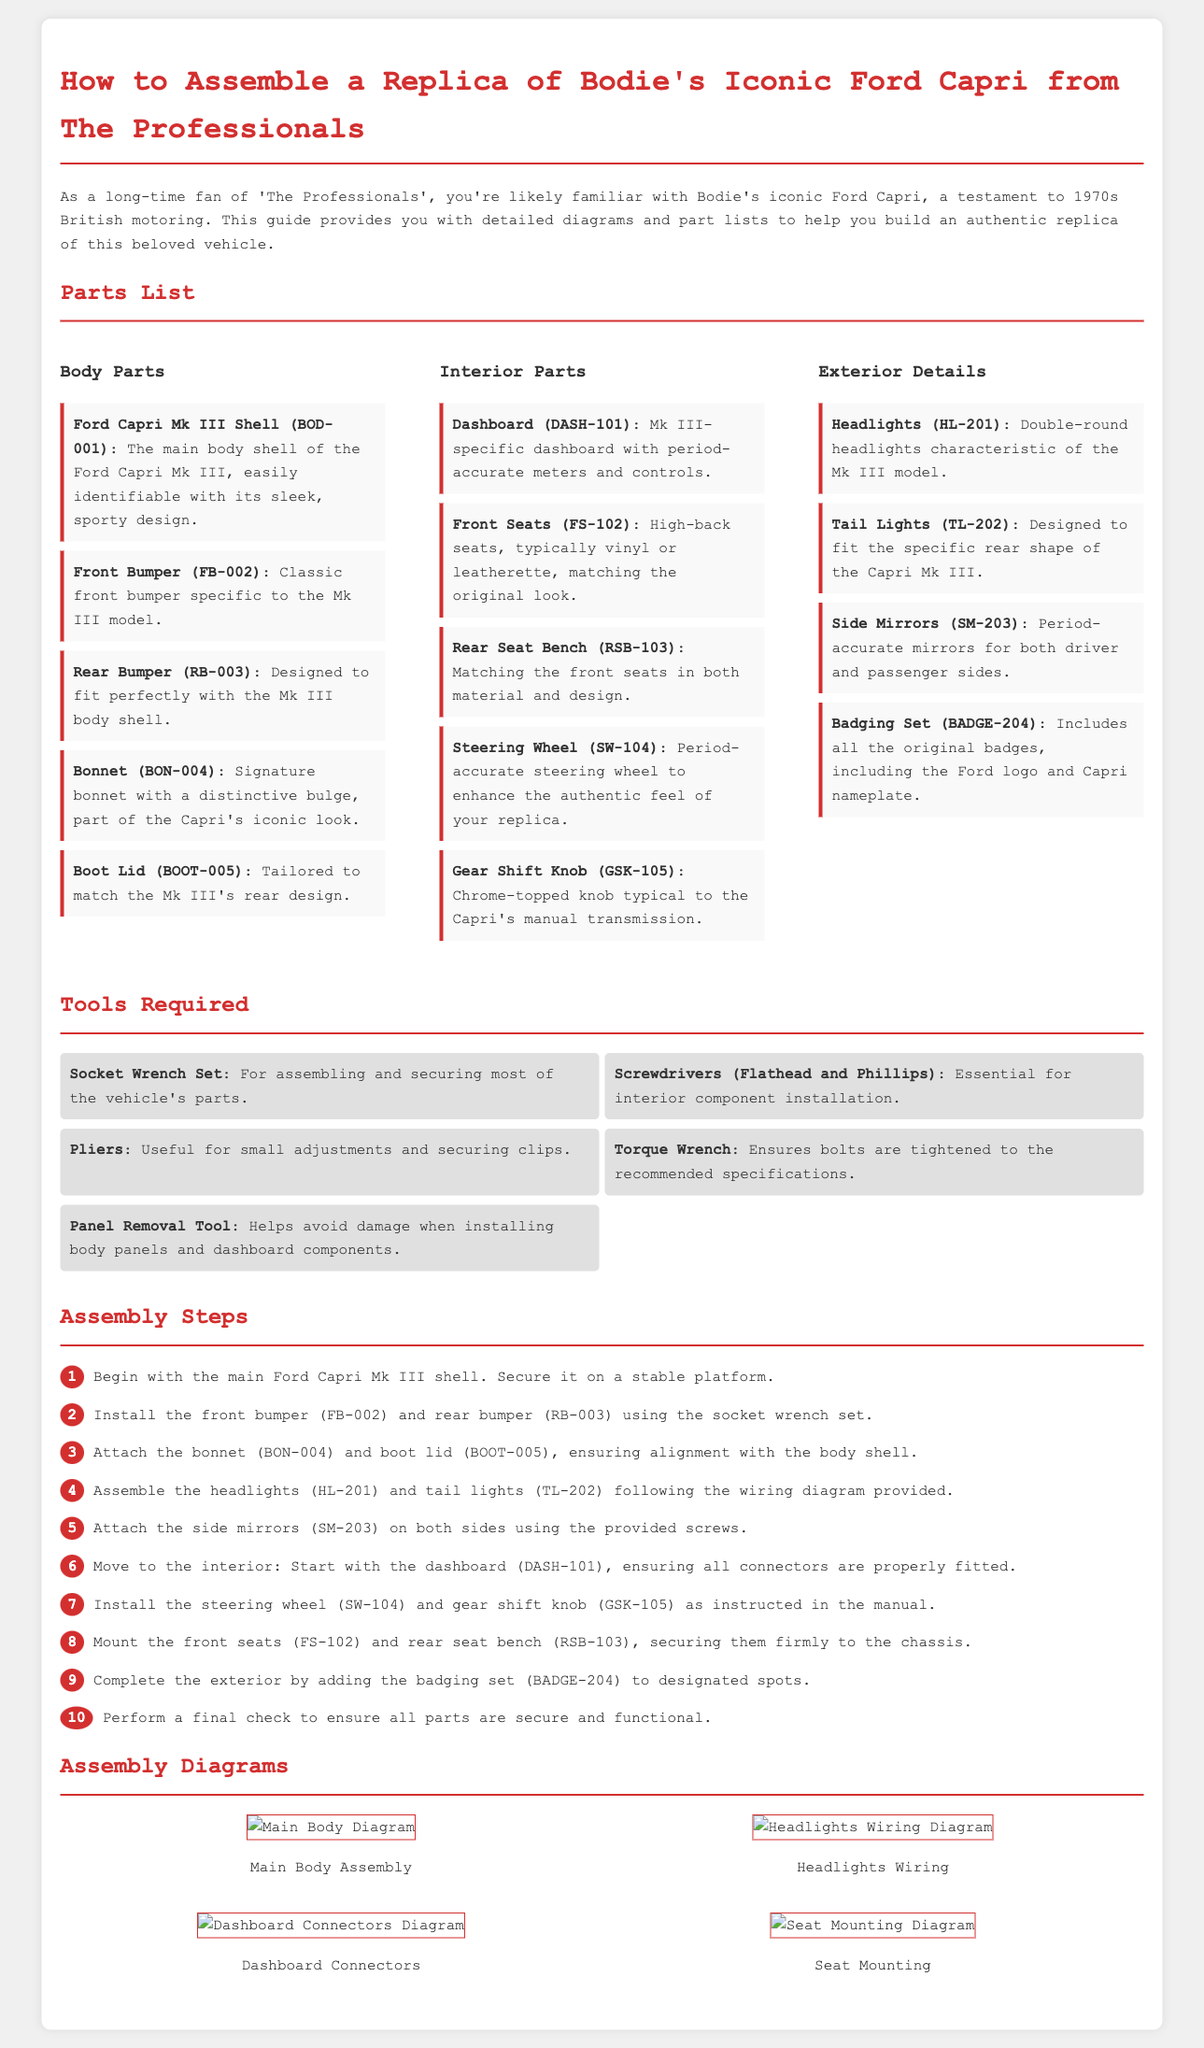What is the main body shell part number? The part number for the Ford Capri Mk III Shell is included in the parts list.
Answer: BOD-001 How many tools are listed in the Tools Required section? The Tools Required section lists essential tools needed for the assembly.
Answer: 5 What is the name of the part for the rear of the vehicle? The document describes the rear part needed for the vehicle assembly.
Answer: Boot Lid Which part is described as characteristic of the Mk III model? The document specifies certain parts that are unique to the Mk III model.
Answer: Headlights What color is used for the titles in the document? The document uses a specific color for section headings that enhances visibility.
Answer: Red What is the last assembly step in the instructions? The final assembly step concludes the building process detailed in the instructions.
Answer: Perform a final check How many categories of parts are listed? The document organizes parts into different categories for clarity in assembly.
Answer: 3 What is the part number for the steering wheel? The part number for the Steering Wheel is essential for identification during assembly.
Answer: SW-104 What type of diagram shows the seat mounting? Diagrams are used to visually depict different aspects of the assembly process.
Answer: Seat Mounting Diagram 